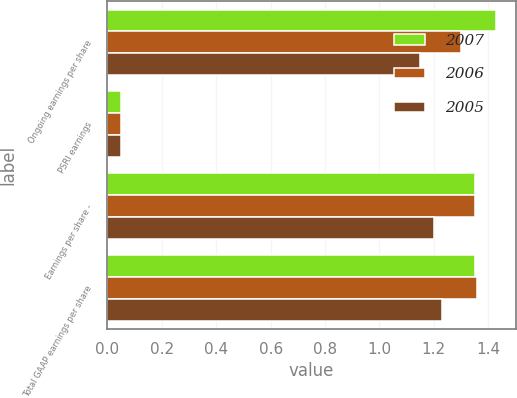Convert chart. <chart><loc_0><loc_0><loc_500><loc_500><stacked_bar_chart><ecel><fcel>Ongoing earnings per share<fcel>PSRI earnings<fcel>Earnings per share -<fcel>Total GAAP earnings per share<nl><fcel>2007<fcel>1.43<fcel>0.05<fcel>1.35<fcel>1.35<nl><fcel>2006<fcel>1.3<fcel>0.05<fcel>1.35<fcel>1.36<nl><fcel>2005<fcel>1.15<fcel>0.05<fcel>1.2<fcel>1.23<nl></chart> 